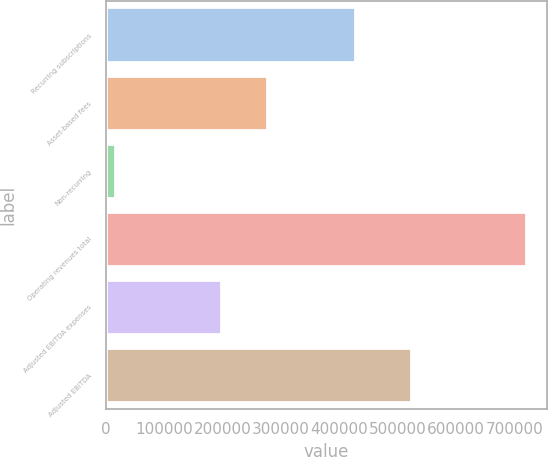Convert chart. <chart><loc_0><loc_0><loc_500><loc_500><bar_chart><fcel>Recurring subscriptions<fcel>Asset-based fees<fcel>Non-recurring<fcel>Operating revenues total<fcel>Adjusted EBITDA expenses<fcel>Adjusted EBITDA<nl><fcel>427289<fcel>276092<fcel>15578<fcel>718959<fcel>196718<fcel>522241<nl></chart> 